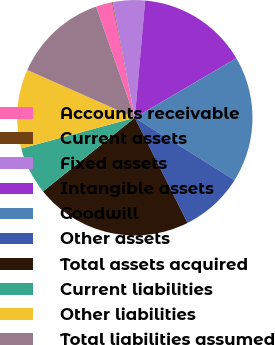<chart> <loc_0><loc_0><loc_500><loc_500><pie_chart><fcel>Accounts receivable<fcel>Current assets<fcel>Fixed assets<fcel>Intangible assets<fcel>Goodwill<fcel>Other assets<fcel>Total assets acquired<fcel>Current liabilities<fcel>Other liabilities<fcel>Total liabilities assumed<nl><fcel>2.24%<fcel>0.09%<fcel>4.4%<fcel>15.17%<fcel>17.33%<fcel>8.71%<fcel>21.64%<fcel>6.55%<fcel>10.86%<fcel>13.02%<nl></chart> 